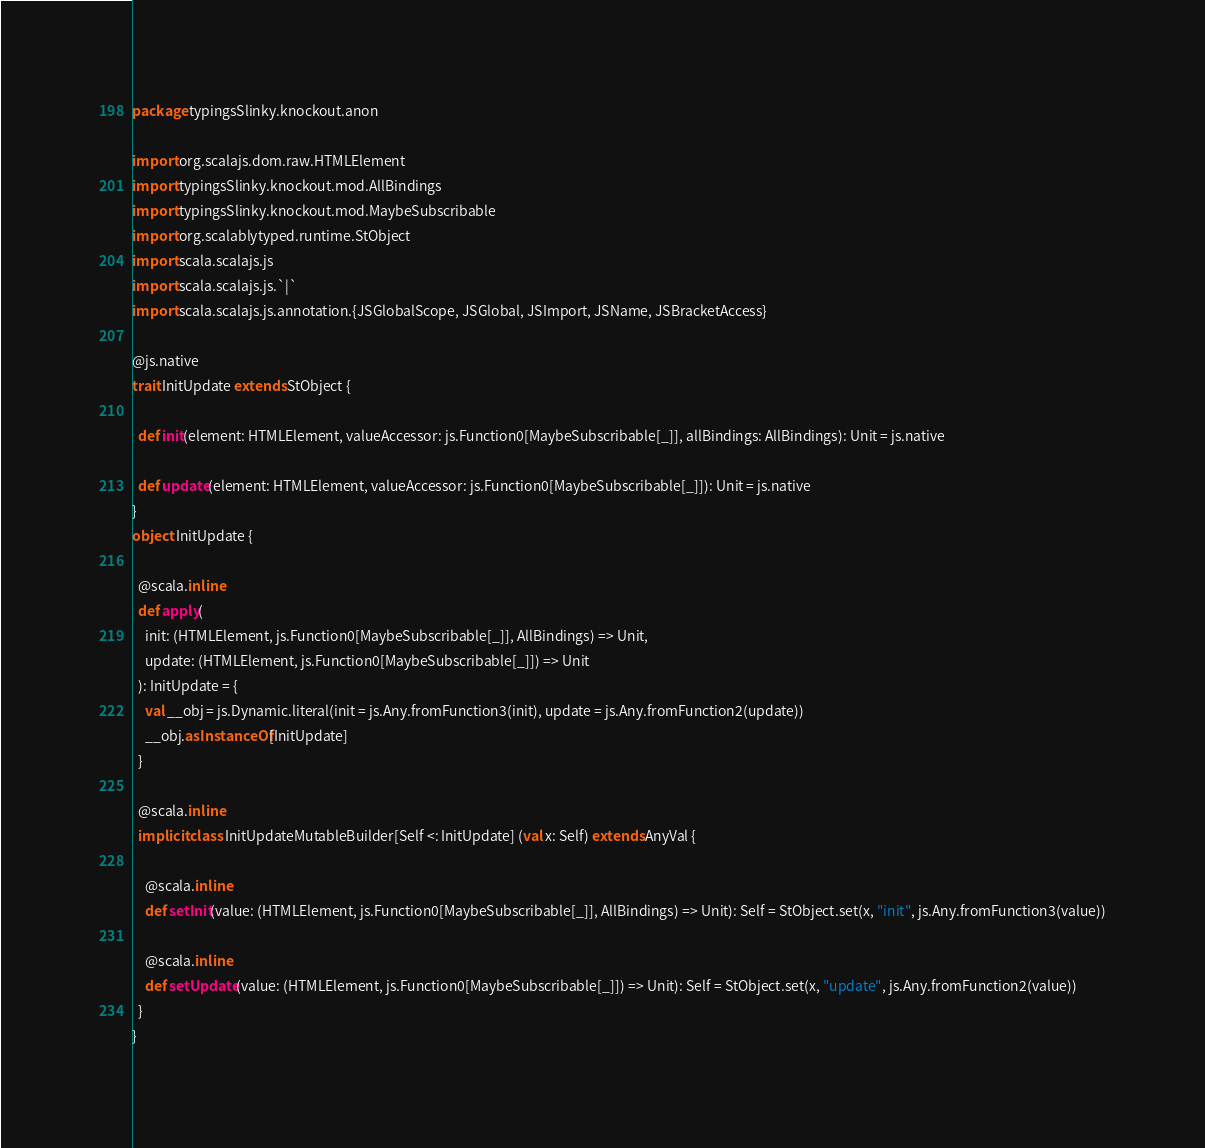<code> <loc_0><loc_0><loc_500><loc_500><_Scala_>package typingsSlinky.knockout.anon

import org.scalajs.dom.raw.HTMLElement
import typingsSlinky.knockout.mod.AllBindings
import typingsSlinky.knockout.mod.MaybeSubscribable
import org.scalablytyped.runtime.StObject
import scala.scalajs.js
import scala.scalajs.js.`|`
import scala.scalajs.js.annotation.{JSGlobalScope, JSGlobal, JSImport, JSName, JSBracketAccess}

@js.native
trait InitUpdate extends StObject {
  
  def init(element: HTMLElement, valueAccessor: js.Function0[MaybeSubscribable[_]], allBindings: AllBindings): Unit = js.native
  
  def update(element: HTMLElement, valueAccessor: js.Function0[MaybeSubscribable[_]]): Unit = js.native
}
object InitUpdate {
  
  @scala.inline
  def apply(
    init: (HTMLElement, js.Function0[MaybeSubscribable[_]], AllBindings) => Unit,
    update: (HTMLElement, js.Function0[MaybeSubscribable[_]]) => Unit
  ): InitUpdate = {
    val __obj = js.Dynamic.literal(init = js.Any.fromFunction3(init), update = js.Any.fromFunction2(update))
    __obj.asInstanceOf[InitUpdate]
  }
  
  @scala.inline
  implicit class InitUpdateMutableBuilder[Self <: InitUpdate] (val x: Self) extends AnyVal {
    
    @scala.inline
    def setInit(value: (HTMLElement, js.Function0[MaybeSubscribable[_]], AllBindings) => Unit): Self = StObject.set(x, "init", js.Any.fromFunction3(value))
    
    @scala.inline
    def setUpdate(value: (HTMLElement, js.Function0[MaybeSubscribable[_]]) => Unit): Self = StObject.set(x, "update", js.Any.fromFunction2(value))
  }
}
</code> 